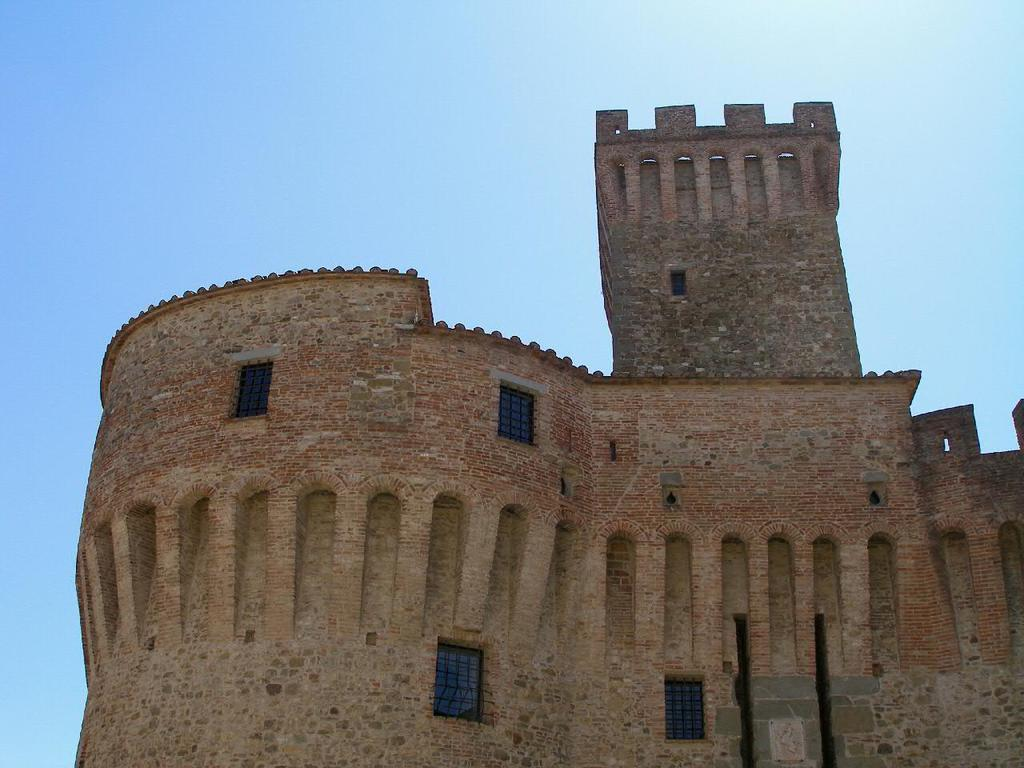What type of structure is visible in the image? There is a fort in the image. Can you describe the fort in more detail? Unfortunately, the provided facts do not offer any additional details about the fort. Is there any vegetation or other structures visible near the fort? The provided facts do not mention any other structures or vegetation near the fort. What type of reward is the girl holding in the image? There is no girl or reward present in the image; it only features a fort. 